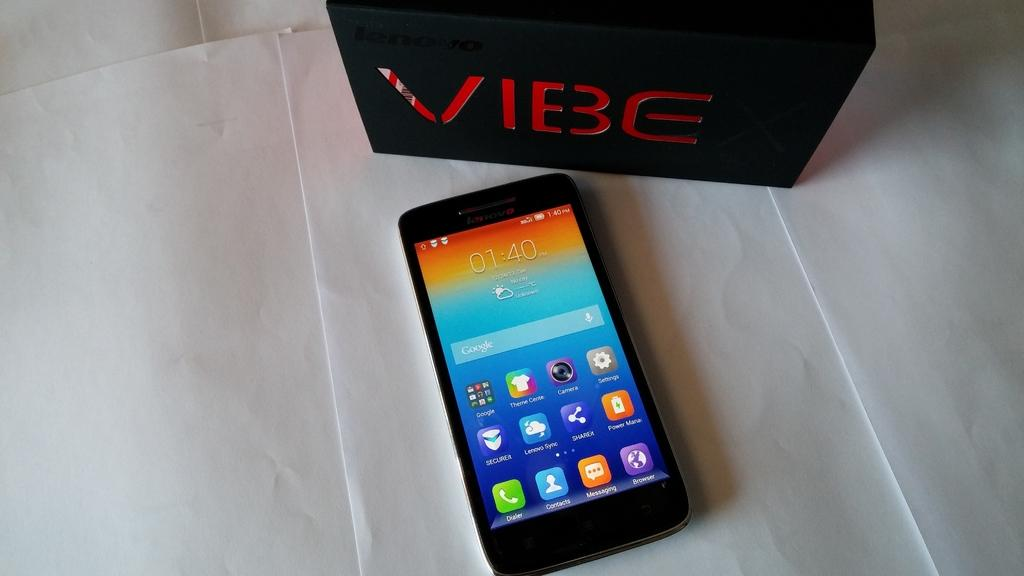Provide a one-sentence caption for the provided image. Vibe box with a cell phone in the front. 